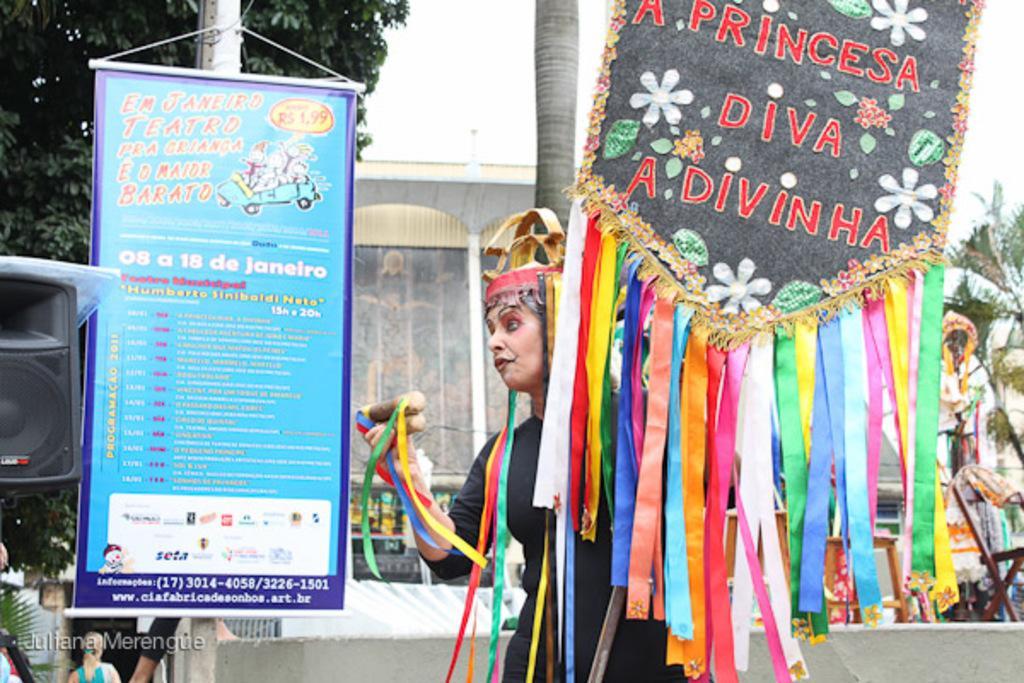Describe this image in one or two sentences. In this picture I can see a human holding a board with some text and I can see an advertisement board to the pole with some text and I can see a tree and a sound box and few people are standing and I can see a building on the back and I can see a bus and a cloudy sky. 